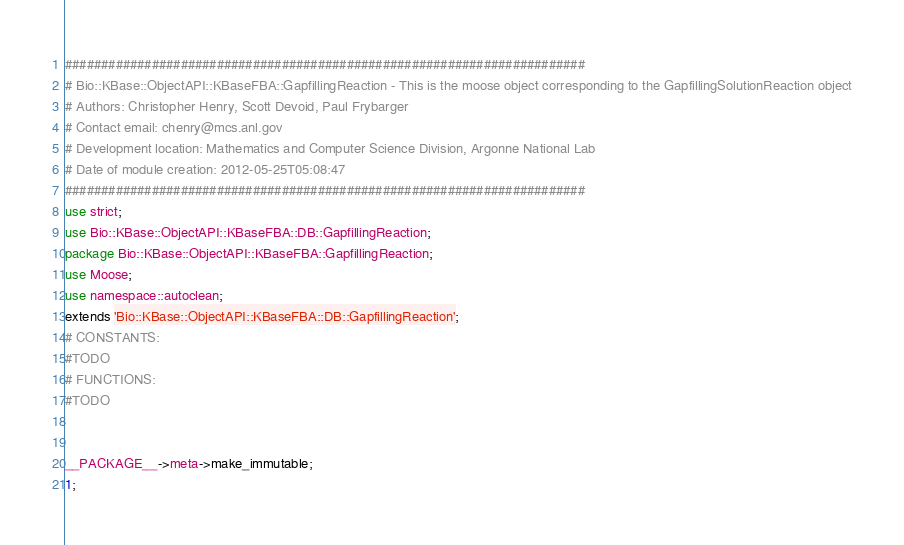Convert code to text. <code><loc_0><loc_0><loc_500><loc_500><_Perl_>########################################################################
# Bio::KBase::ObjectAPI::KBaseFBA::GapfillingReaction - This is the moose object corresponding to the GapfillingSolutionReaction object
# Authors: Christopher Henry, Scott Devoid, Paul Frybarger
# Contact email: chenry@mcs.anl.gov
# Development location: Mathematics and Computer Science Division, Argonne National Lab
# Date of module creation: 2012-05-25T05:08:47
########################################################################
use strict;
use Bio::KBase::ObjectAPI::KBaseFBA::DB::GapfillingReaction;
package Bio::KBase::ObjectAPI::KBaseFBA::GapfillingReaction;
use Moose;
use namespace::autoclean;
extends 'Bio::KBase::ObjectAPI::KBaseFBA::DB::GapfillingReaction';
# CONSTANTS:
#TODO
# FUNCTIONS:
#TODO


__PACKAGE__->meta->make_immutable;
1;
</code> 